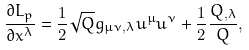Convert formula to latex. <formula><loc_0><loc_0><loc_500><loc_500>\frac { \partial L _ { p } } { \partial x ^ { \lambda } } = \frac { 1 } { 2 } \sqrt { Q } g _ { \mu \nu , \lambda } u ^ { \mu } u ^ { \nu } + \frac { 1 } { 2 } \frac { Q _ { , \lambda } } { Q } ,</formula> 